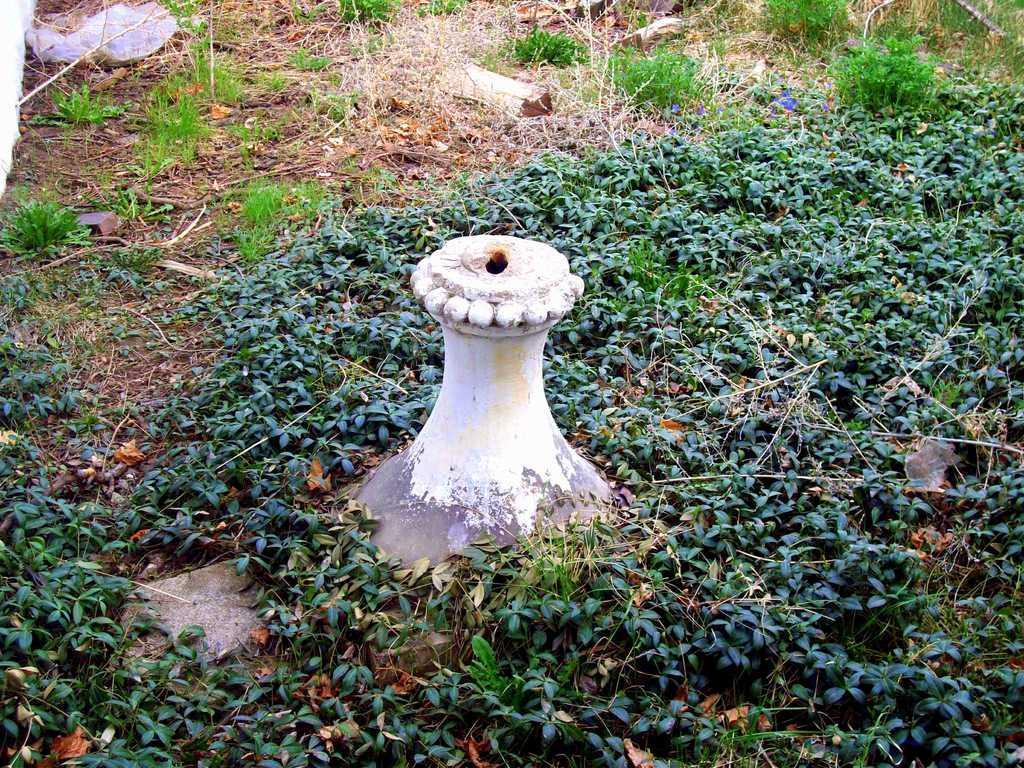In one or two sentences, can you explain what this image depicts? In this picture, we see grass on the ground. 